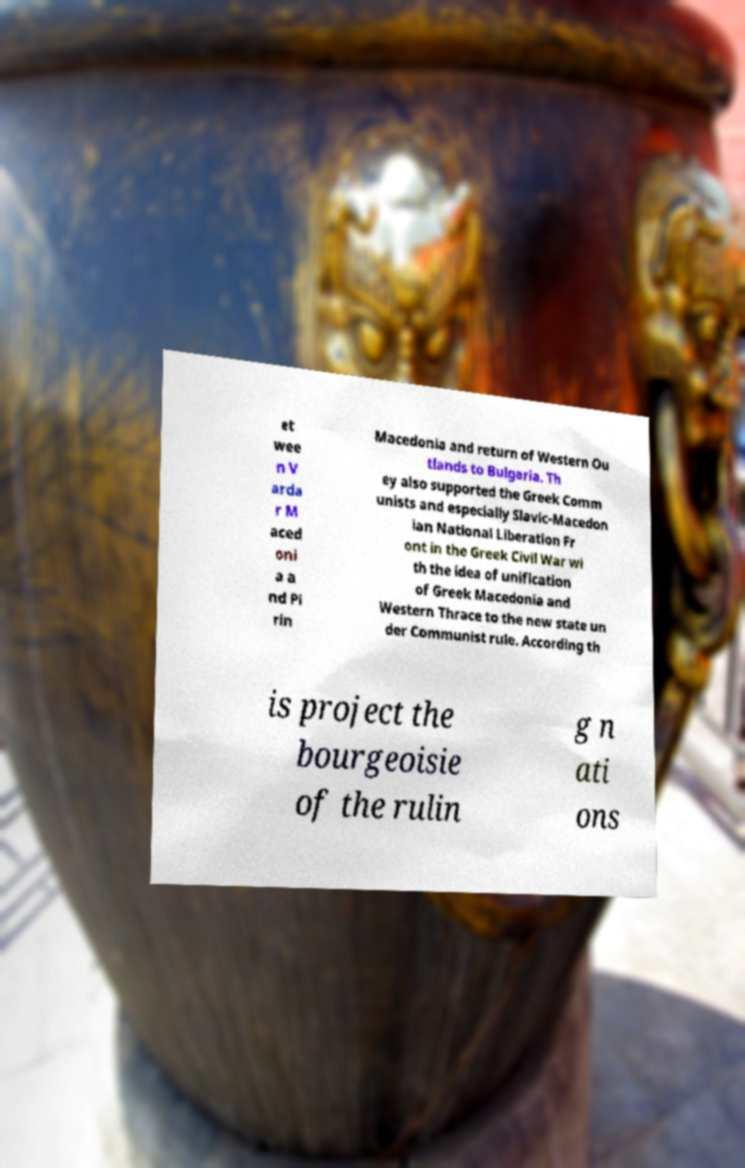Could you extract and type out the text from this image? et wee n V arda r M aced oni a a nd Pi rin Macedonia and return of Western Ou tlands to Bulgaria. Th ey also supported the Greek Comm unists and especially Slavic-Macedon ian National Liberation Fr ont in the Greek Civil War wi th the idea of unification of Greek Macedonia and Western Thrace to the new state un der Communist rule. According th is project the bourgeoisie of the rulin g n ati ons 